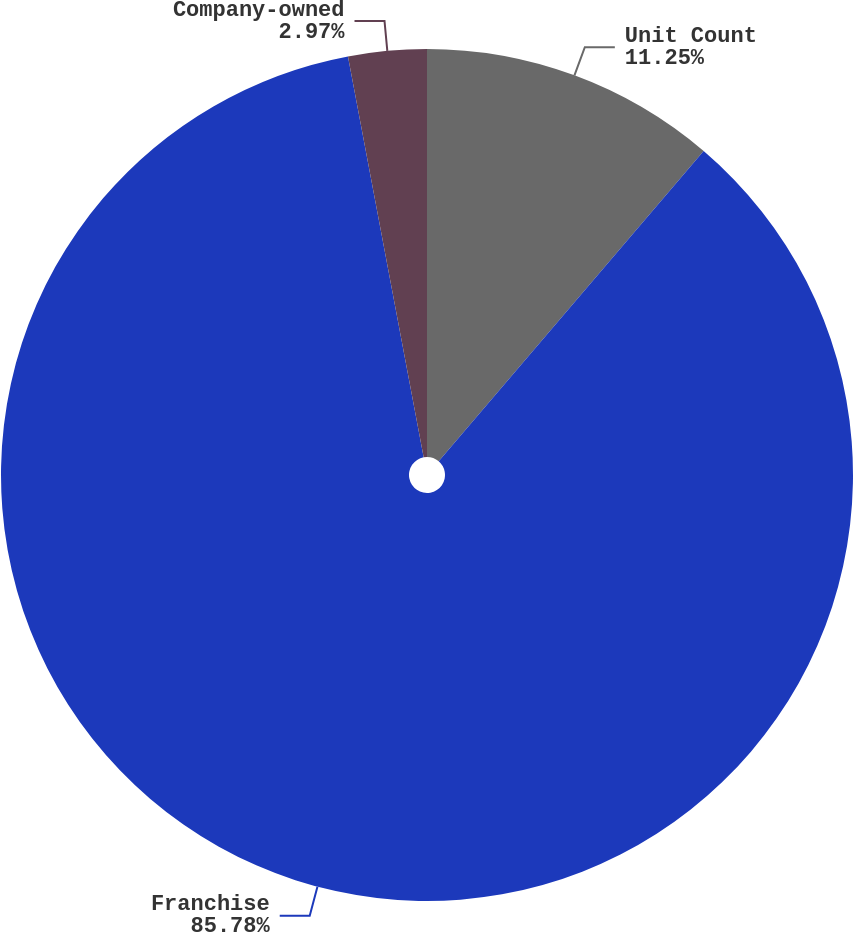<chart> <loc_0><loc_0><loc_500><loc_500><pie_chart><fcel>Unit Count<fcel>Franchise<fcel>Company-owned<nl><fcel>11.25%<fcel>85.78%<fcel>2.97%<nl></chart> 